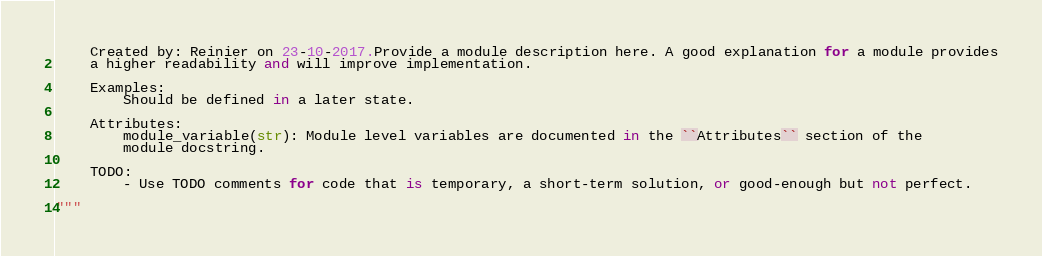Convert code to text. <code><loc_0><loc_0><loc_500><loc_500><_Python_>    Created by: Reinier on 23-10-2017.Provide a module description here. A good explanation for a module provides
    a higher readability and will improve implementation.
    
    Examples:
        Should be defined in a later state.
    
    Attributes:
        module_variable(str): Module level variables are documented in the ``Attributes`` section of the
        module docstring.
        
    TODO:
        - Use TODO comments for code that is temporary, a short-term solution, or good-enough but not perfect.
        
"""
</code> 